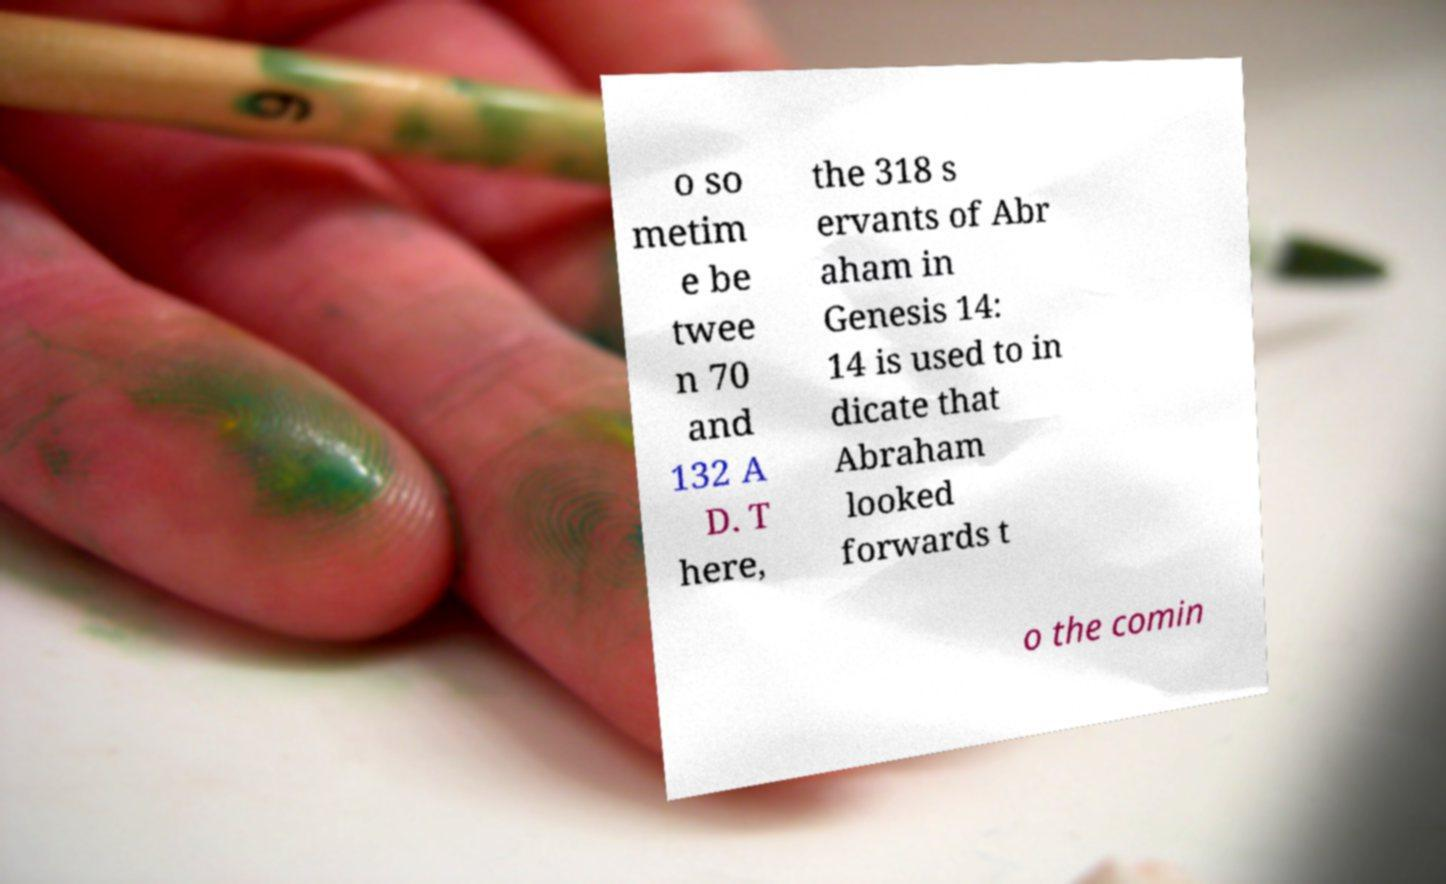What messages or text are displayed in this image? I need them in a readable, typed format. o so metim e be twee n 70 and 132 A D. T here, the 318 s ervants of Abr aham in Genesis 14: 14 is used to in dicate that Abraham looked forwards t o the comin 